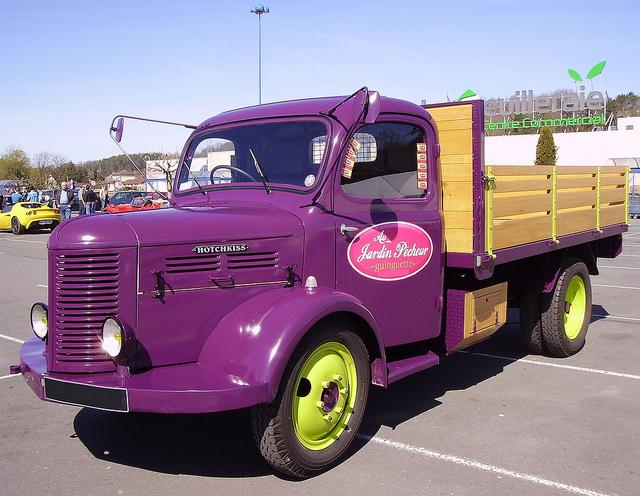Which television character is the same color as this truck? barney 